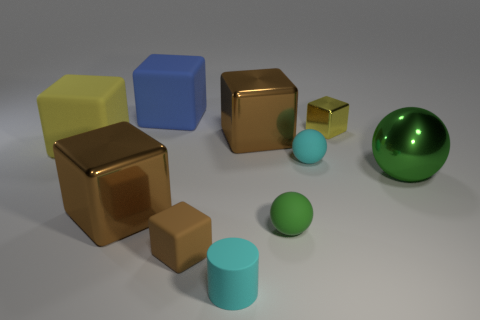Subtract all blue cylinders. How many brown blocks are left? 3 Subtract all yellow blocks. How many blocks are left? 4 Subtract all small brown cubes. How many cubes are left? 5 Subtract all gray blocks. Subtract all green balls. How many blocks are left? 6 Subtract all balls. How many objects are left? 7 Add 2 blue matte objects. How many blue matte objects exist? 3 Subtract 0 cyan blocks. How many objects are left? 10 Subtract all large rubber things. Subtract all big green metal balls. How many objects are left? 7 Add 3 brown objects. How many brown objects are left? 6 